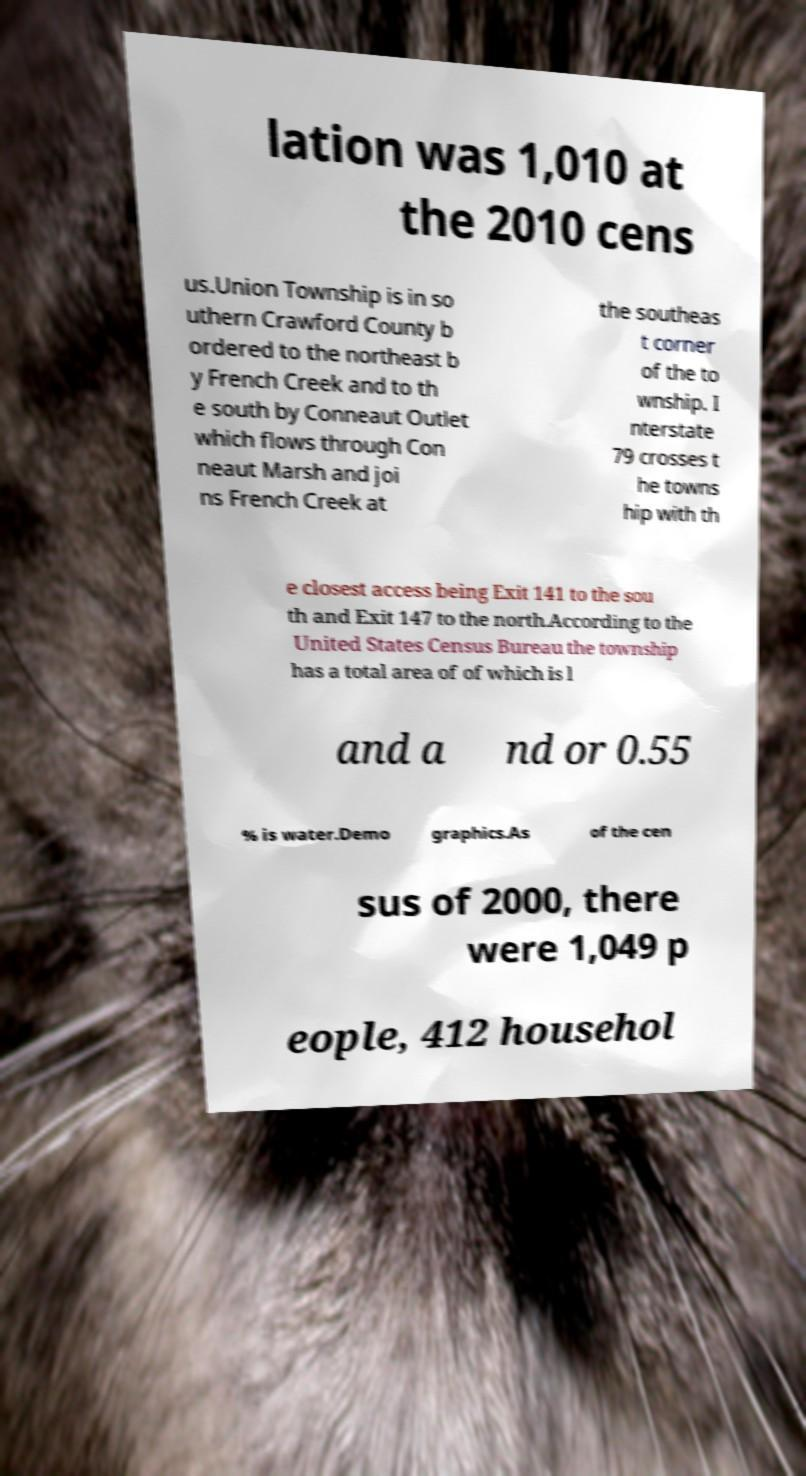Can you read and provide the text displayed in the image?This photo seems to have some interesting text. Can you extract and type it out for me? lation was 1,010 at the 2010 cens us.Union Township is in so uthern Crawford County b ordered to the northeast b y French Creek and to th e south by Conneaut Outlet which flows through Con neaut Marsh and joi ns French Creek at the southeas t corner of the to wnship. I nterstate 79 crosses t he towns hip with th e closest access being Exit 141 to the sou th and Exit 147 to the north.According to the United States Census Bureau the township has a total area of of which is l and a nd or 0.55 % is water.Demo graphics.As of the cen sus of 2000, there were 1,049 p eople, 412 househol 